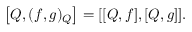Convert formula to latex. <formula><loc_0><loc_0><loc_500><loc_500>\left [ Q , ( f , g ) _ { Q } \right ] = [ [ Q , f ] , [ Q , g ] ] .</formula> 